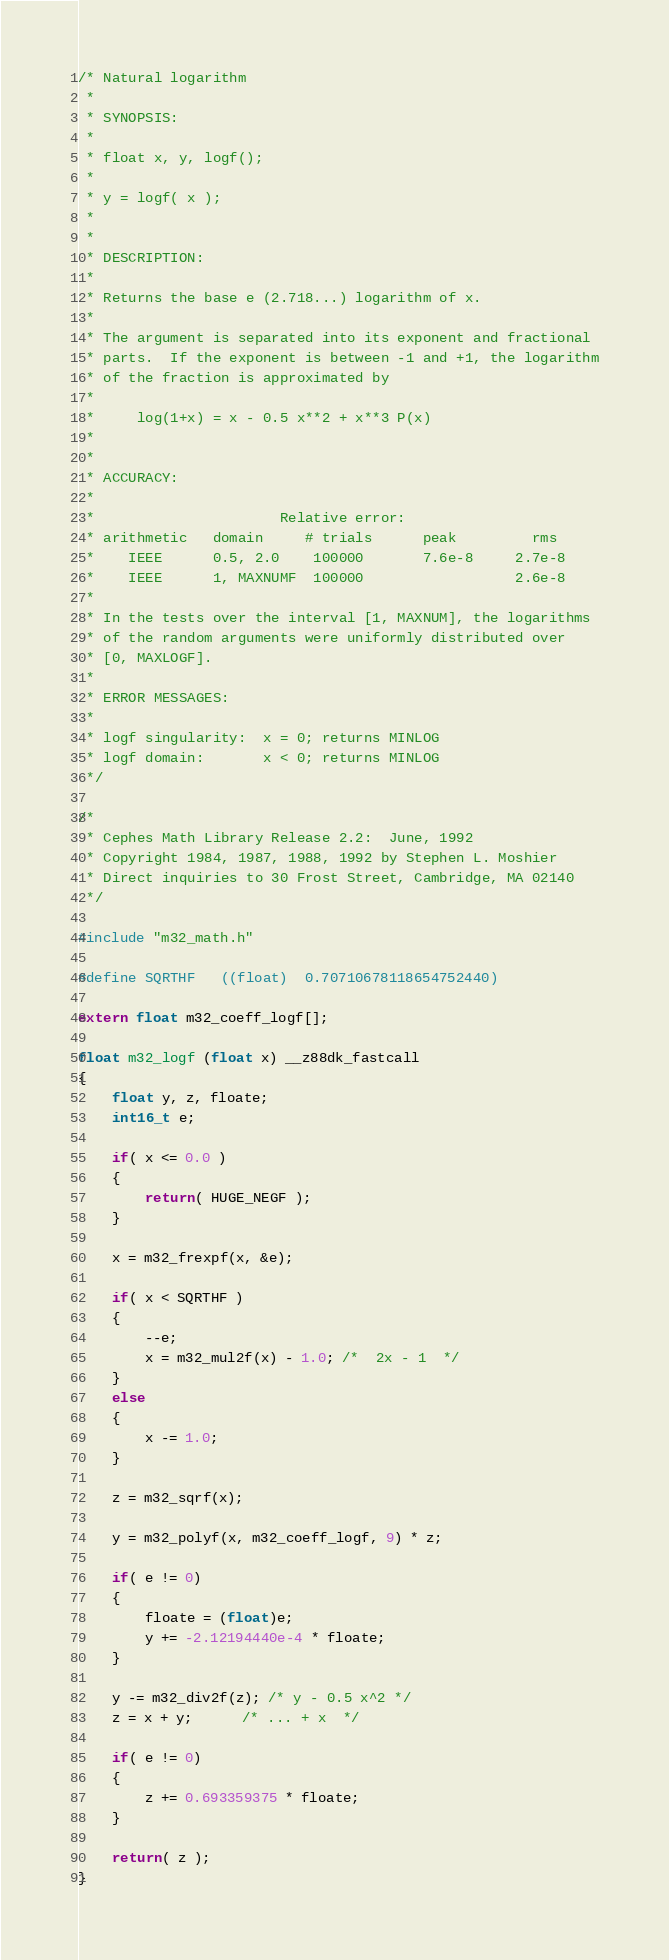<code> <loc_0><loc_0><loc_500><loc_500><_C_>/* Natural logarithm
 *
 * SYNOPSIS:
 *
 * float x, y, logf();
 *
 * y = logf( x );
 *
 *
 * DESCRIPTION:
 *
 * Returns the base e (2.718...) logarithm of x.
 *
 * The argument is separated into its exponent and fractional
 * parts.  If the exponent is between -1 and +1, the logarithm
 * of the fraction is approximated by
 *
 *     log(1+x) = x - 0.5 x**2 + x**3 P(x)
 *
 *
 * ACCURACY:
 *
 *                      Relative error:
 * arithmetic   domain     # trials      peak         rms
 *    IEEE      0.5, 2.0    100000       7.6e-8     2.7e-8
 *    IEEE      1, MAXNUMF  100000                  2.6e-8
 *
 * In the tests over the interval [1, MAXNUM], the logarithms
 * of the random arguments were uniformly distributed over
 * [0, MAXLOGF].
 *
 * ERROR MESSAGES:
 *
 * logf singularity:  x = 0; returns MINLOG
 * logf domain:       x < 0; returns MINLOG
 */

/*
 * Cephes Math Library Release 2.2:  June, 1992
 * Copyright 1984, 1987, 1988, 1992 by Stephen L. Moshier
 * Direct inquiries to 30 Frost Street, Cambridge, MA 02140
 */
 
#include "m32_math.h"

#define SQRTHF   ((float)  0.70710678118654752440)

extern float m32_coeff_logf[];

float m32_logf (float x) __z88dk_fastcall
{
    float y, z, floate;
    int16_t e;

    if( x <= 0.0 )
    {
        return( HUGE_NEGF );
    }

    x = m32_frexpf(x, &e);

    if( x < SQRTHF )
    {
        --e;
        x = m32_mul2f(x) - 1.0; /*  2x - 1  */
    }
    else
    {
        x -= 1.0;
    }

    z = m32_sqrf(x);

    y = m32_polyf(x, m32_coeff_logf, 9) * z;
 
    if( e != 0)
    {
        floate = (float)e;
        y += -2.12194440e-4 * floate;
    }

    y -= m32_div2f(z); /* y - 0.5 x^2 */
    z = x + y;      /* ... + x  */

    if( e != 0)
    {
        z += 0.693359375 * floate;
    }

    return( z );
}
</code> 